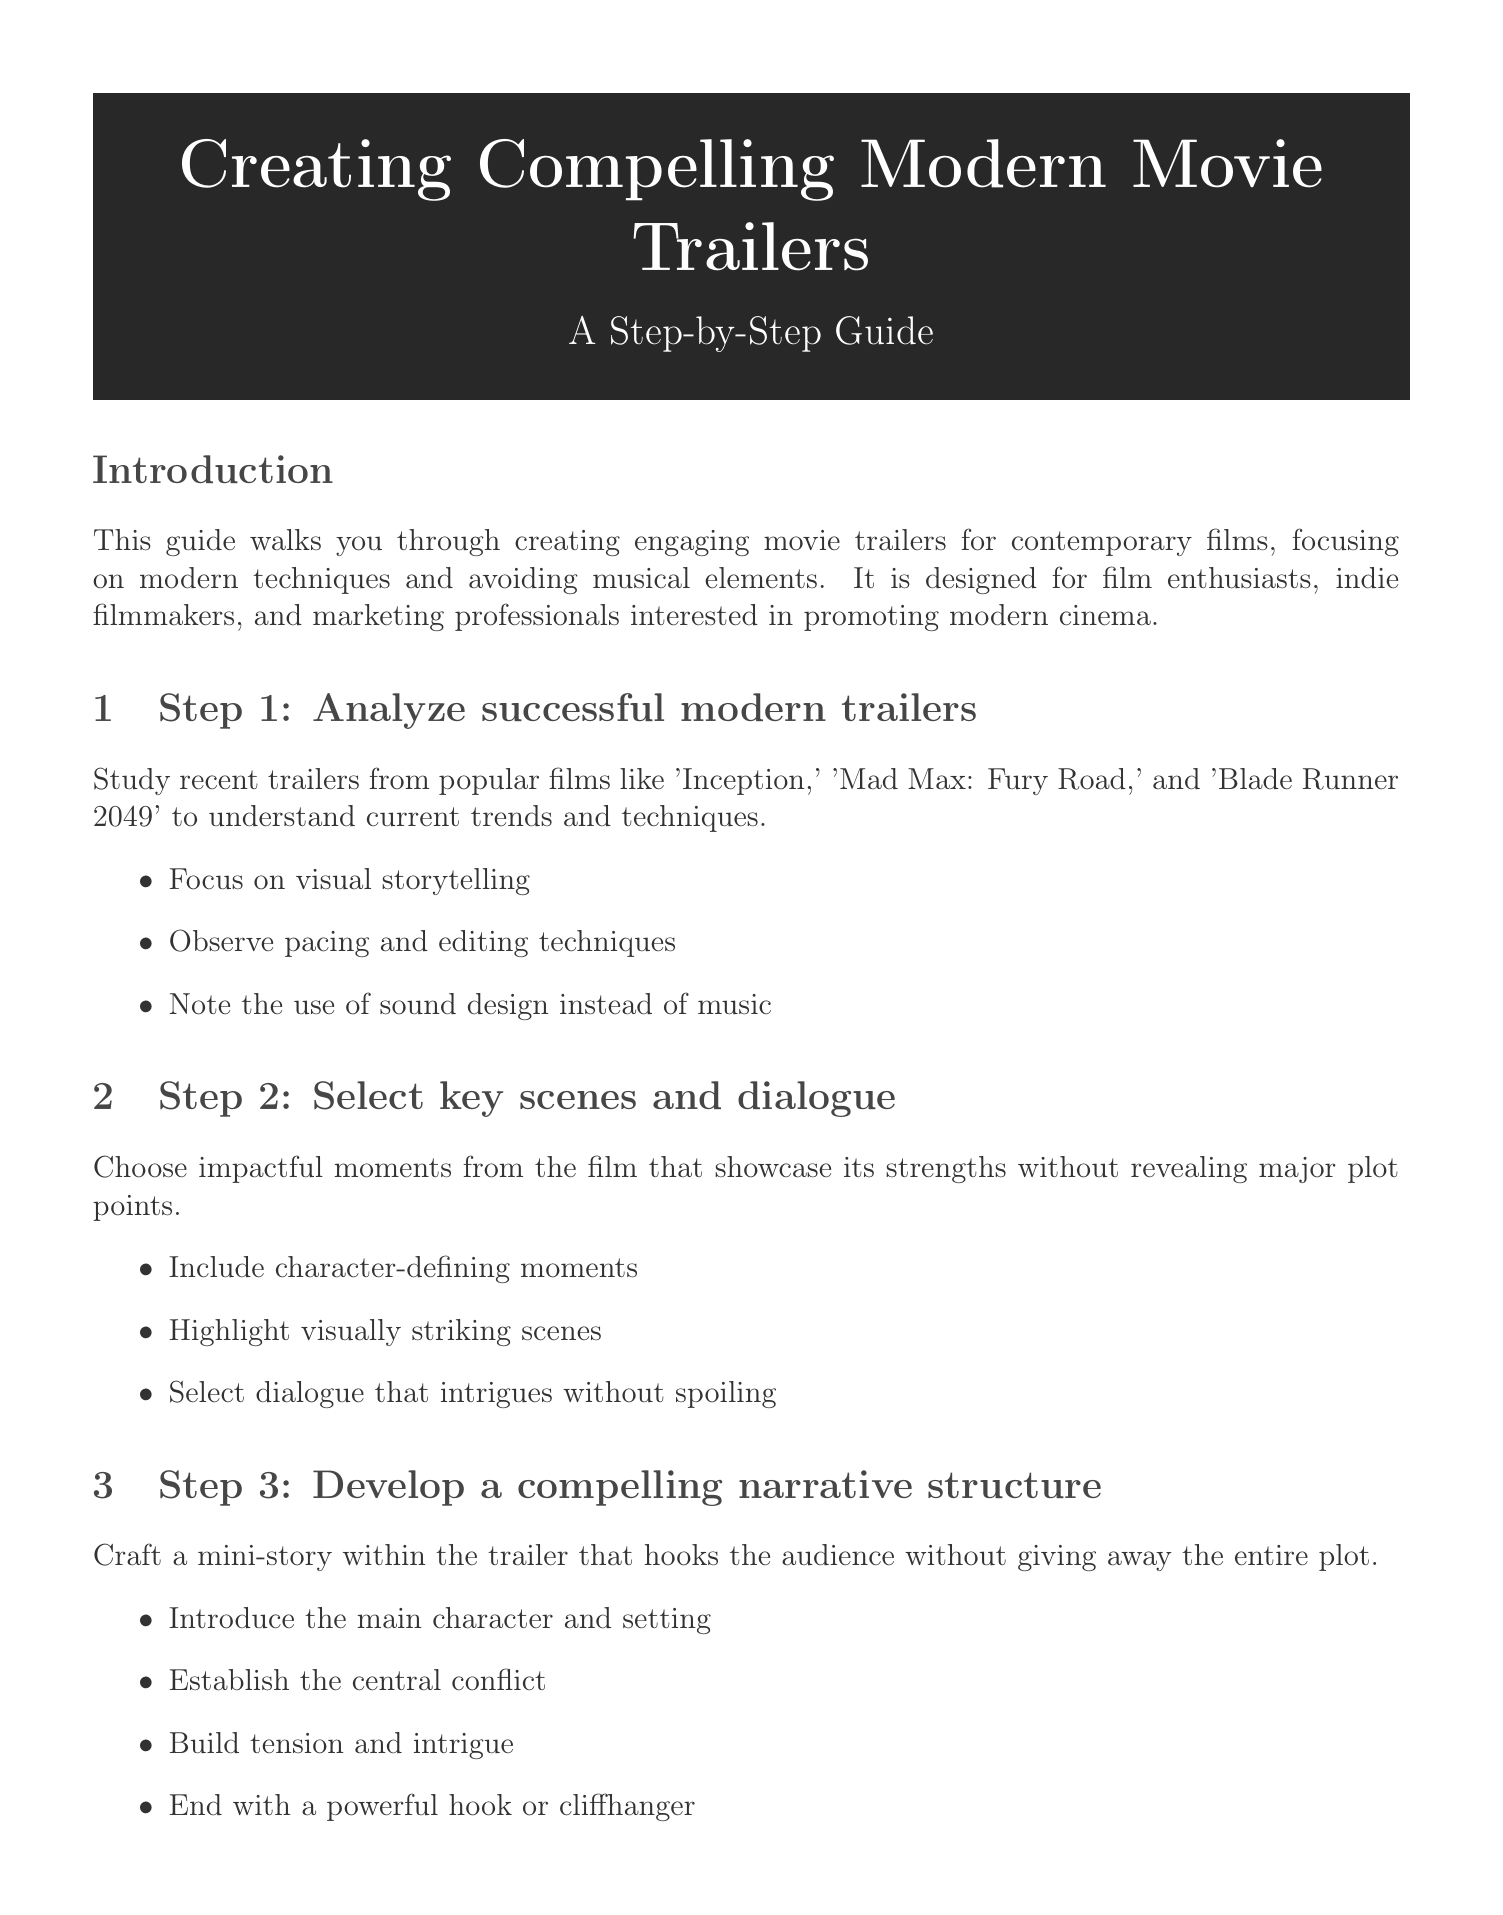What is the title of the manual? The title can be found at the beginning of the document, presenting the focus on creating modern movie trailers.
Answer: Creating Compelling Modern Movie Trailers: A Step-by-Step Guide Who is the target audience for this guide? The introduction specifies who the guide is intended for, outlining the demographics and professions.
Answer: Film enthusiasts, indie filmmakers, and marketing professionals What is the first step in creating a trailer? The document lays out a clear step-by-step process, starting with analyzing successful examples.
Answer: Analyze successful modern trailers How many editing software recommendations are provided? The section on modern editing techniques lists specific software tools available for the task.
Answer: Three What is emphasized over musical scores in sound design? The guide highlights an alternative approach to audio in trailers, focusing on specific sound elements.
Answer: Atmospheric sound design Which movie is cited as a case study for effective use of silence? The case studies section identifies films that exemplify successful trailer strategies, including one focused on silence.
Answer: Arrival What is one of the best practices for trailer creation? The best practices section provides advice for ensuring engaging and effective trailers.
Answer: Maintain a fast pace to hold viewer attention What visual techniques should be used in the trailers? The document details modern techniques that enhance the visual appeal of trailers.
Answer: Subtle CGI enhancements What should the trailer avoid revealing? The best practices specify important content to keep hidden in trailers to maintain intrigue.
Answer: Major plot twists or the film's ending 